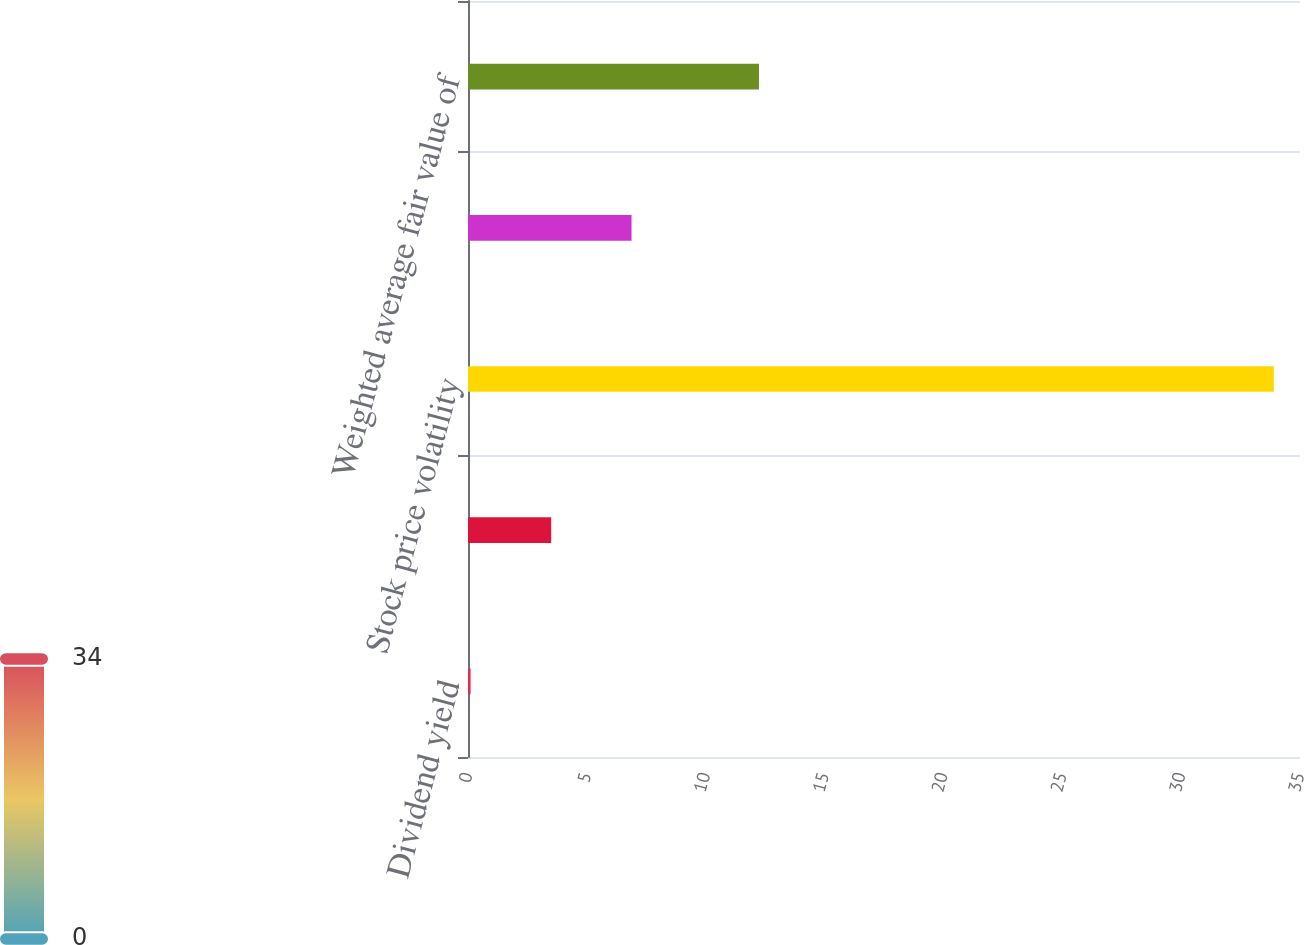Convert chart to OTSL. <chart><loc_0><loc_0><loc_500><loc_500><bar_chart><fcel>Dividend yield<fcel>Risk-free interest rate<fcel>Stock price volatility<fcel>Expected life (years)<fcel>Weighted average fair value of<nl><fcel>0.11<fcel>3.5<fcel>33.9<fcel>6.88<fcel>12.24<nl></chart> 